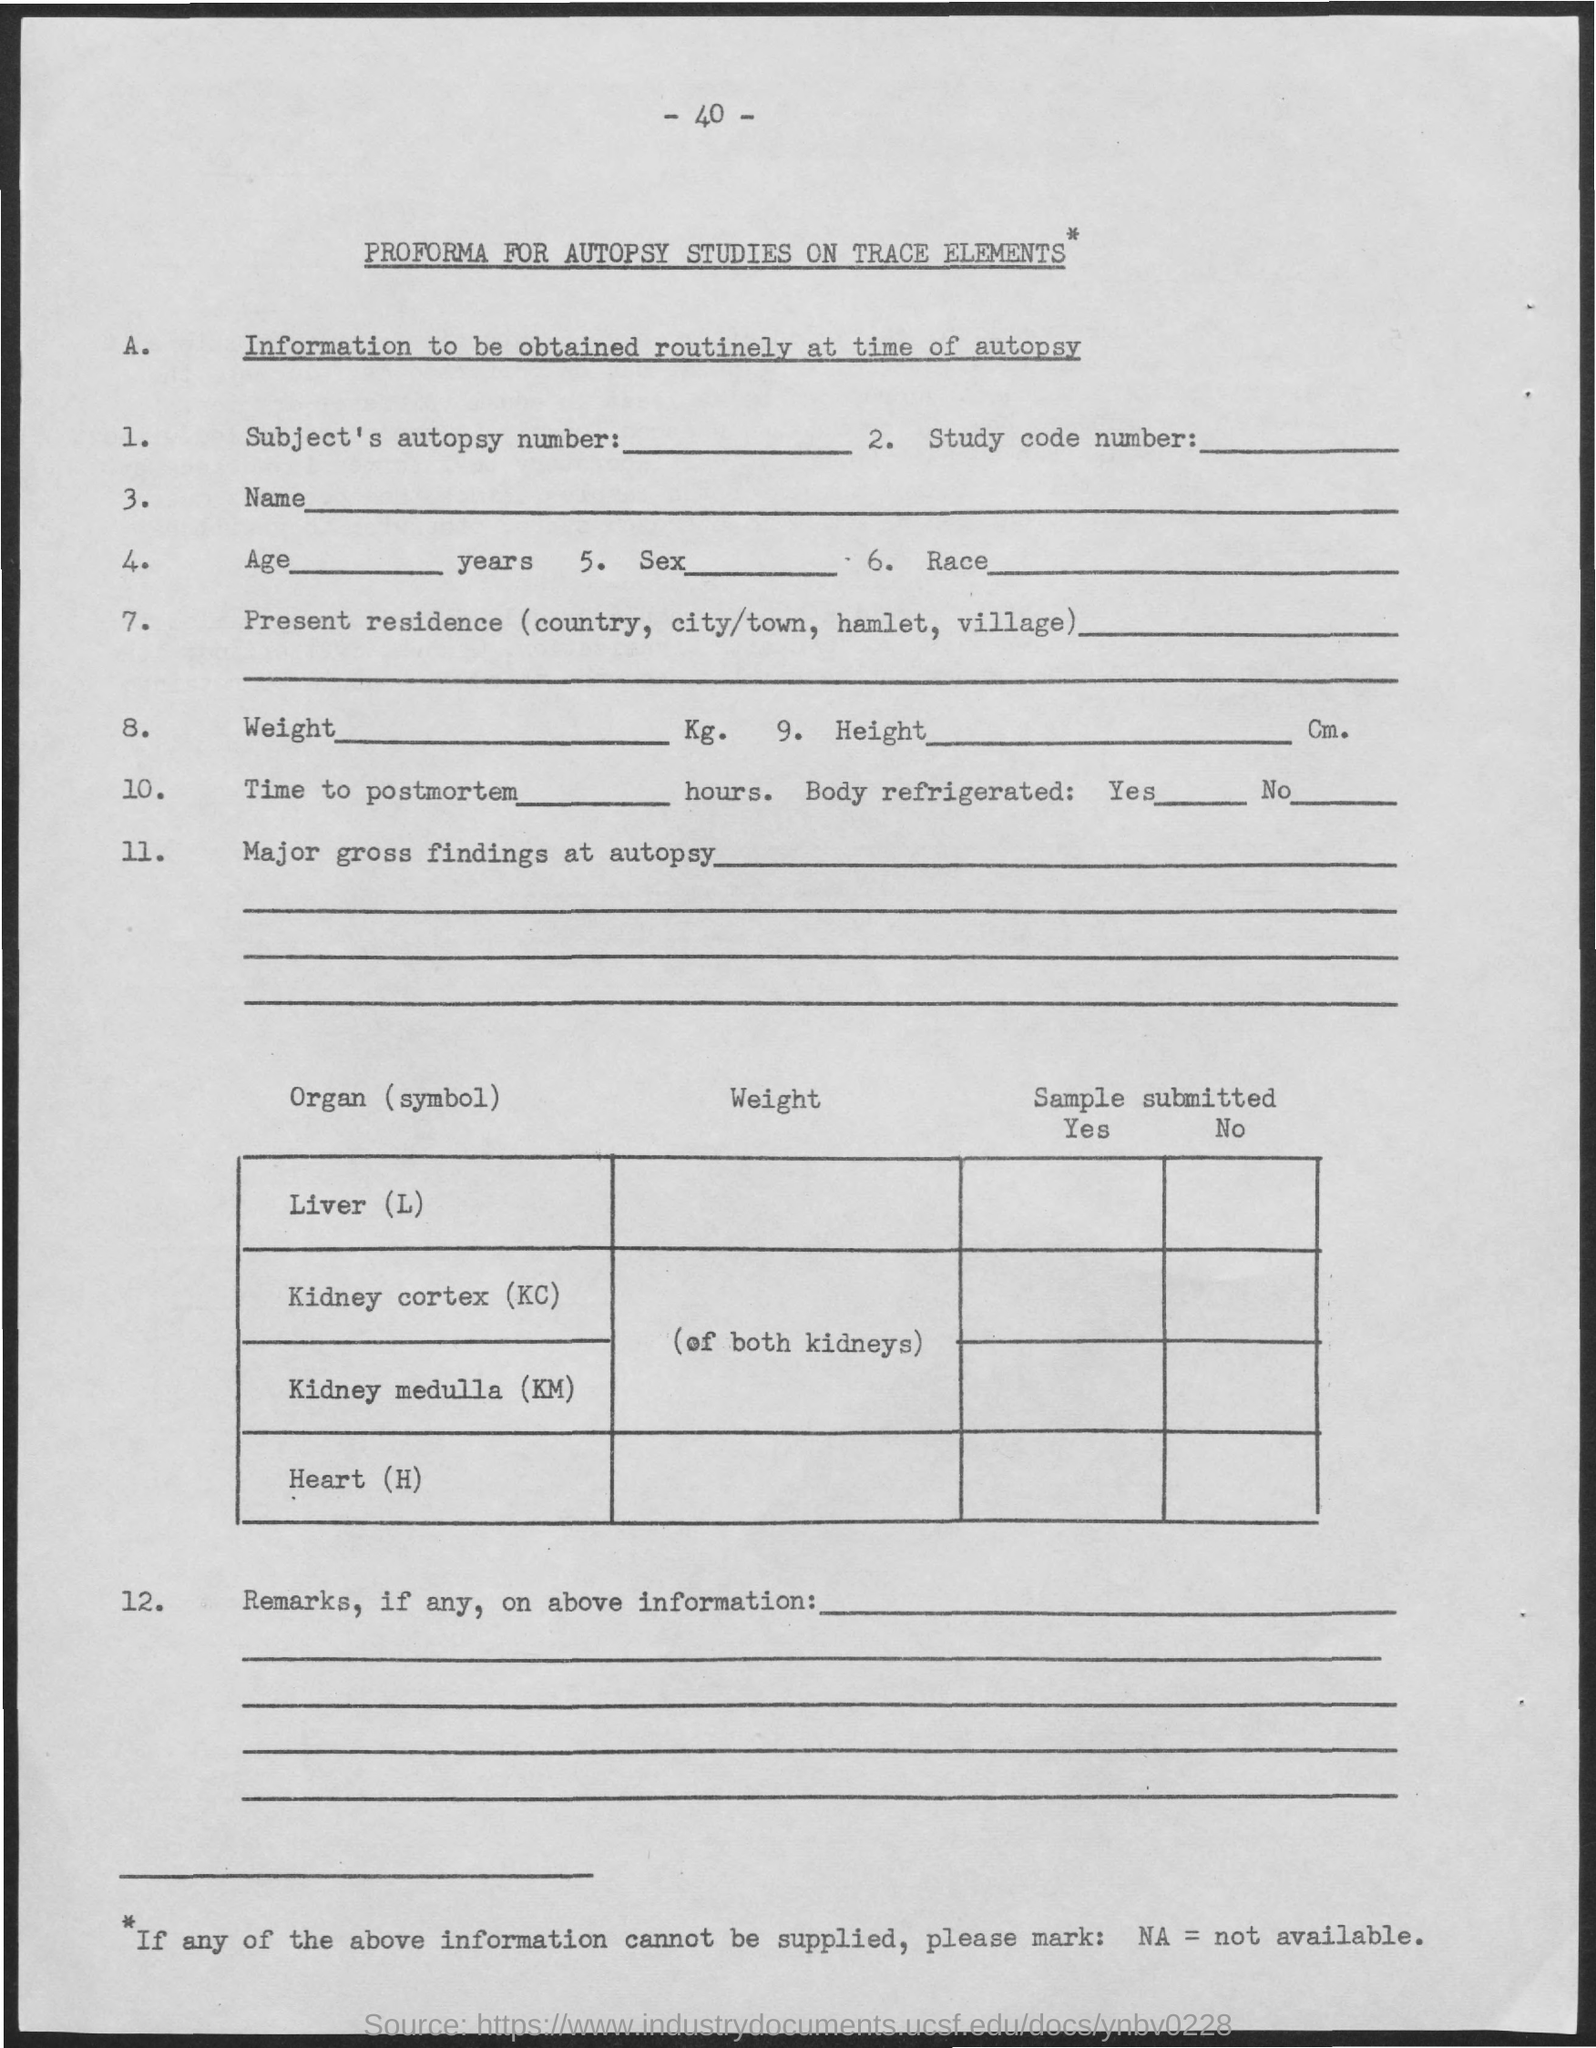What is the full form of NA?
Your answer should be very brief. Not available. What is the Page Number?
Give a very brief answer. 40. 